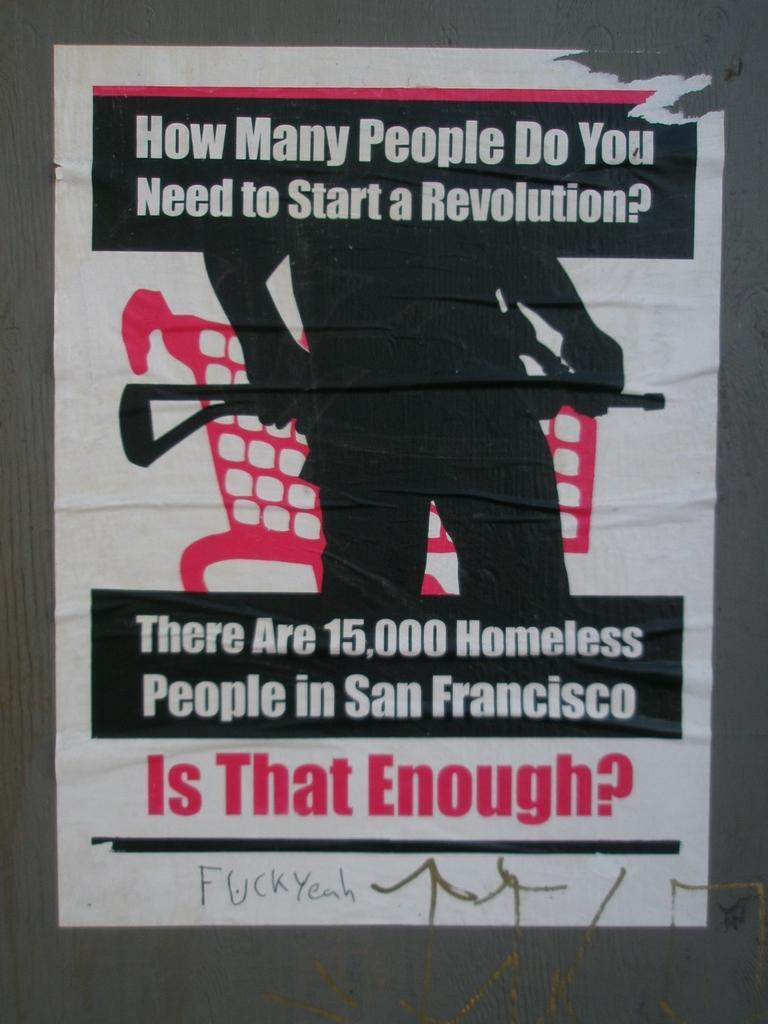In one or two sentences, can you explain what this image depicts? In this image I can see a poster which is attached to the wall. On the poster I can see some text and an image of a person. 